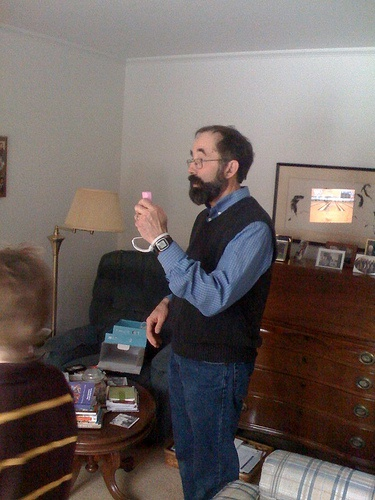Describe the objects in this image and their specific colors. I can see people in gray, black, and navy tones, people in gray, black, and maroon tones, chair in gray and black tones, couch in gray, black, and lightgray tones, and couch in gray, darkgray, and lightgray tones in this image. 